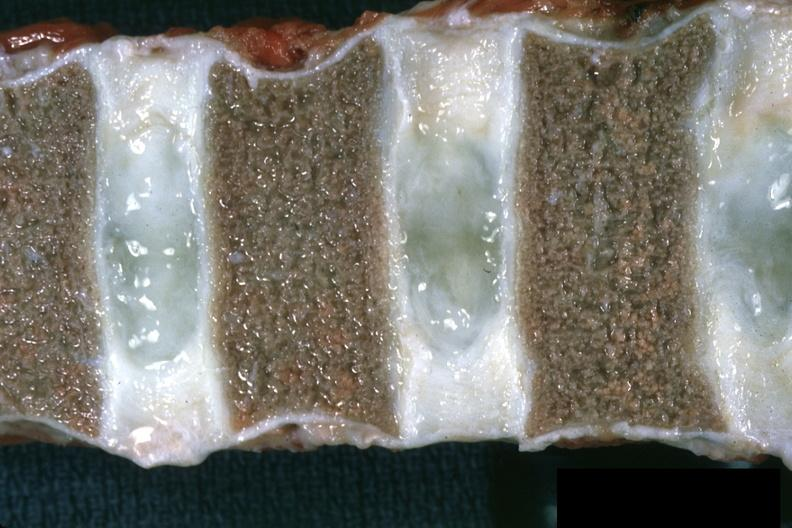what are somewhat collapsed?
Answer the question using a single word or phrase. Close-up view well shown normal discs case of chronic myelogenous leukemia in a 14yo male vertebra 